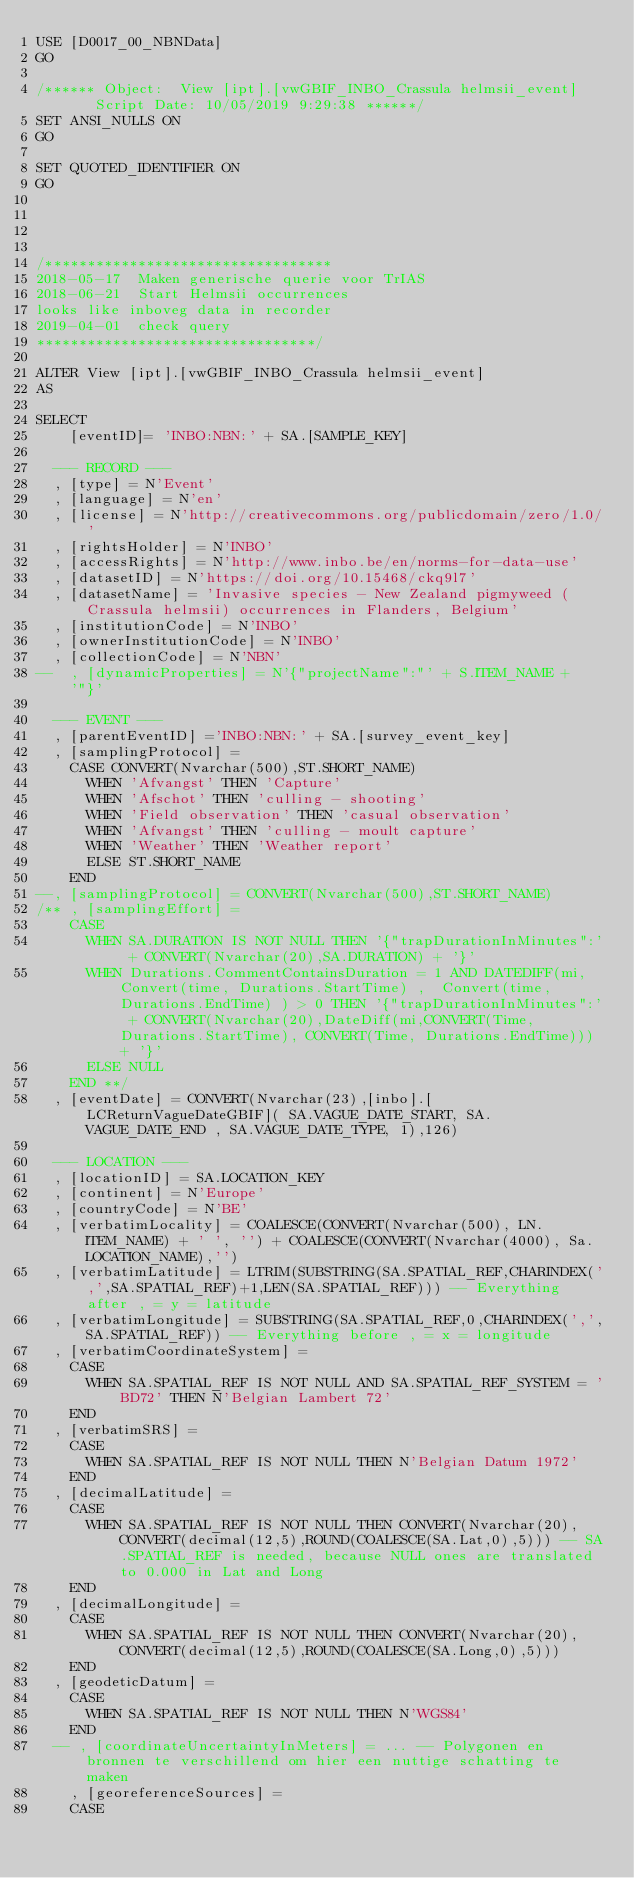Convert code to text. <code><loc_0><loc_0><loc_500><loc_500><_SQL_>USE [D0017_00_NBNData]
GO

/****** Object:  View [ipt].[vwGBIF_INBO_Crassula helmsii_event]    Script Date: 10/05/2019 9:29:38 ******/
SET ANSI_NULLS ON
GO

SET QUOTED_IDENTIFIER ON
GO




/**********************************
2018-05-17  Maken generische querie voor TrIAS
2018-06-21  Start Helmsii occurrences
looks like inboveg data in recorder
2019-04-01  check query
*********************************/

ALTER View [ipt].[vwGBIF_INBO_Crassula helmsii_event]
AS

SELECT 
	  [eventID]= 'INBO:NBN:' + SA.[SAMPLE_KEY]

	--- RECORD ---	
	, [type] = N'Event'
	, [language] = N'en'
	, [license] = N'http://creativecommons.org/publicdomain/zero/1.0/'
	, [rightsHolder] = N'INBO'
	, [accessRights] = N'http://www.inbo.be/en/norms-for-data-use'
	, [datasetID] = N'https://doi.org/10.15468/ckq9l7'
	, [datasetName] = 'Invasive species - New Zealand pigmyweed (Crassula helmsii) occurrences in Flanders, Belgium'
	, [institutionCode] = N'INBO'
	, [ownerInstitutionCode] = N'INBO'
	, [collectionCode] = N'NBN'
--	, [dynamicProperties] = N'{"projectName":"' + S.ITEM_NAME + '"}'

	--- EVENT ---
	, [parentEventID] ='INBO:NBN:' + SA.[survey_event_key]
	, [samplingProtocol] = 
		CASE CONVERT(Nvarchar(500),ST.SHORT_NAME)
			WHEN 'Afvangst' THEN 'Capture'
			WHEN 'Afschot' THEN 'culling - shooting'
			WHEN 'Field observation' THEN 'casual observation'
			WHEN 'Afvangst' THEN 'culling - moult capture'
			WHEN 'Weather' THEN 'Weather report'
			ELSE ST.SHORT_NAME
		END 
--, [samplingProtocol] = CONVERT(Nvarchar(500),ST.SHORT_NAME)
/**	, [samplingEffort] =
		CASE
			WHEN SA.DURATION IS NOT NULL THEN '{"trapDurationInMinutes":' + CONVERT(Nvarchar(20),SA.DURATION) + '}' 
			WHEN Durations.CommentContainsDuration = 1 AND DATEDIFF(mi,Convert(time, Durations.StartTime) ,  Convert(time, Durations.EndTime) ) > 0 THEN '{"trapDurationInMinutes":' + CONVERT(Nvarchar(20),DateDiff(mi,CONVERT(Time, Durations.StartTime), CONVERT(Time, Durations.EndTime))) + '}' 
			ELSE NULL
		END **/
	, [eventDate] = CONVERT(Nvarchar(23),[inbo].[LCReturnVagueDateGBIF]( SA.VAGUE_DATE_START, SA.VAGUE_DATE_END , SA.VAGUE_DATE_TYPE, 1),126)
	
	--- LOCATION ---
	, [locationID] = SA.LOCATION_KEY
	, [continent] = N'Europe'
	, [countryCode] = N'BE'
	, [verbatimLocality] = COALESCE(CONVERT(Nvarchar(500), LN.ITEM_NAME) + ' ', '') + COALESCE(CONVERT(Nvarchar(4000), Sa.LOCATION_NAME),'')
	, [verbatimLatitude] = LTRIM(SUBSTRING(SA.SPATIAL_REF,CHARINDEX(',',SA.SPATIAL_REF)+1,LEN(SA.SPATIAL_REF))) -- Everything after , = y = latitude
	, [verbatimLongitude] = SUBSTRING(SA.SPATIAL_REF,0,CHARINDEX(',',SA.SPATIAL_REF)) -- Everything before , = x = longitude
	, [verbatimCoordinateSystem] =
		CASE
			WHEN SA.SPATIAL_REF IS NOT NULL AND SA.SPATIAL_REF_SYSTEM = 'BD72' THEN N'Belgian Lambert 72'
		END
	, [verbatimSRS] = 
		CASE 
			WHEN SA.SPATIAL_REF IS NOT NULL THEN N'Belgian Datum 1972'
		END
	, [decimalLatitude] = 
		CASE
			WHEN SA.SPATIAL_REF IS NOT NULL THEN CONVERT(Nvarchar(20),CONVERT(decimal(12,5),ROUND(COALESCE(SA.Lat,0),5))) -- SA.SPATIAL_REF is needed, because NULL ones are translated to 0.000 in Lat and Long
		END
	, [decimalLongitude] = 
		CASE
			WHEN SA.SPATIAL_REF IS NOT NULL THEN CONVERT(Nvarchar(20),CONVERT(decimal(12,5),ROUND(COALESCE(SA.Long,0),5)))
		END
	, [geodeticDatum] = 
		CASE 
			WHEN SA.SPATIAL_REF IS NOT NULL THEN N'WGS84'
		END
	-- , [coordinateUncertaintyInMeters] = ... -- Polygonen en bronnen te verschillend om hier een nuttige schatting te maken
    , [georeferenceSources] = 
		CASE</code> 